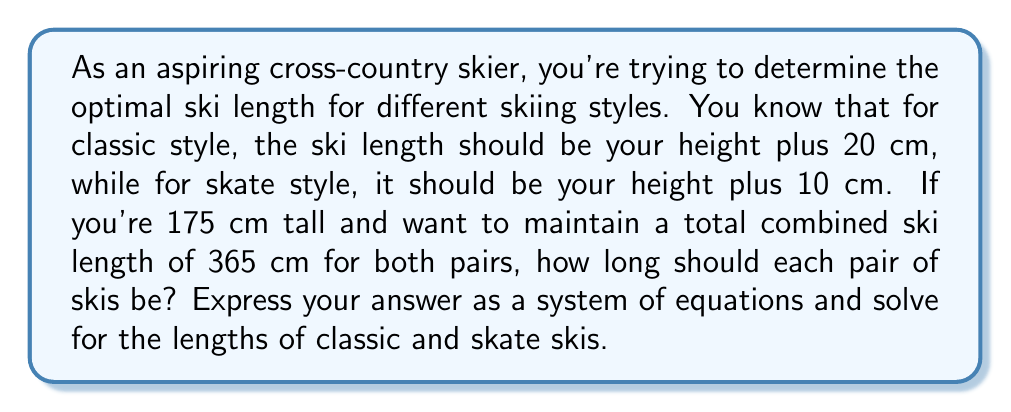Teach me how to tackle this problem. Let's approach this step-by-step:

1) Let $x$ be the length of classic skis and $y$ be the length of skate skis.

2) From the given information, we can form two equations:

   Equation 1: $x = 175 + 20$ (classic ski length)
   Equation 2: $y = 175 + 10$ (skate ski length)

3) We also know that the total combined length should be 365 cm:

   Equation 3: $x + y = 365$

4) Now we have a system of equations:

   $$\begin{cases}
   x = 195 \\
   y = 185 \\
   x + y = 365
   \end{cases}$$

5) We can solve this by substitution. Let's substitute the values of $x$ and $y$ from the first two equations into the third:

   $195 + 185 = 365$

6) Indeed, this equation is true, confirming our solution.

Therefore, the classic skis should be 195 cm long, and the skate skis should be 185 cm long.
Answer: Classic skis: 195 cm, Skate skis: 185 cm 